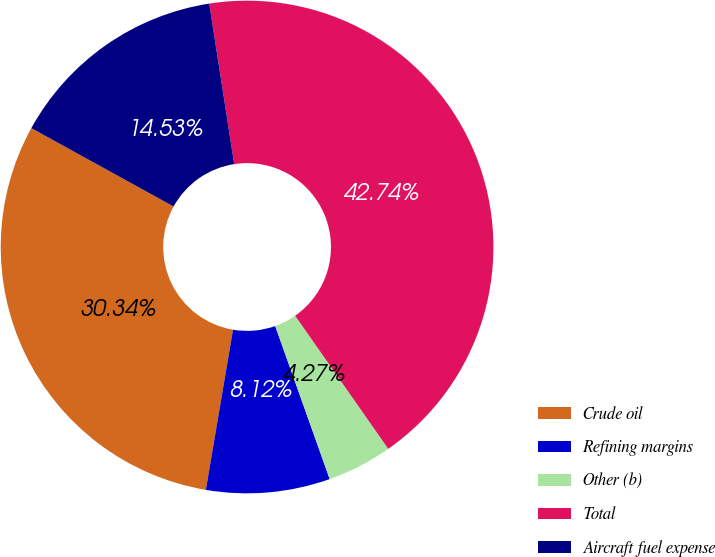Convert chart. <chart><loc_0><loc_0><loc_500><loc_500><pie_chart><fcel>Crude oil<fcel>Refining margins<fcel>Other (b)<fcel>Total<fcel>Aircraft fuel expense<nl><fcel>30.34%<fcel>8.12%<fcel>4.27%<fcel>42.74%<fcel>14.53%<nl></chart> 